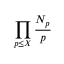<formula> <loc_0><loc_0><loc_500><loc_500>\prod _ { p \leq X } { \frac { N _ { p } } { p } }</formula> 